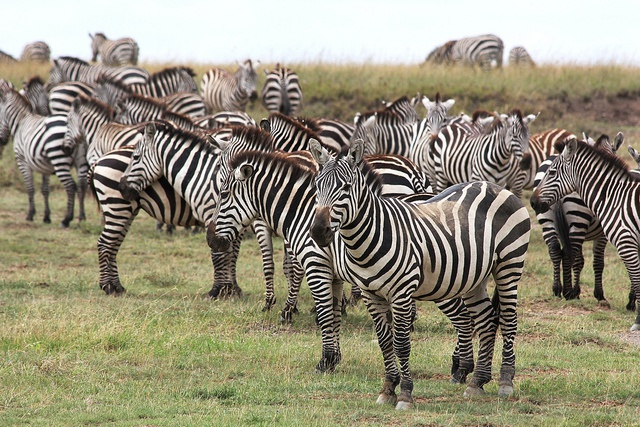Describe the objects in this image and their specific colors. I can see zebra in white, black, gray, tan, and darkgray tones, zebra in white, black, gray, darkgray, and lightgray tones, zebra in white, black, lightgray, gray, and darkgray tones, zebra in white, black, gray, lightgray, and darkgray tones, and zebra in white, black, lightgray, gray, and darkgray tones in this image. 